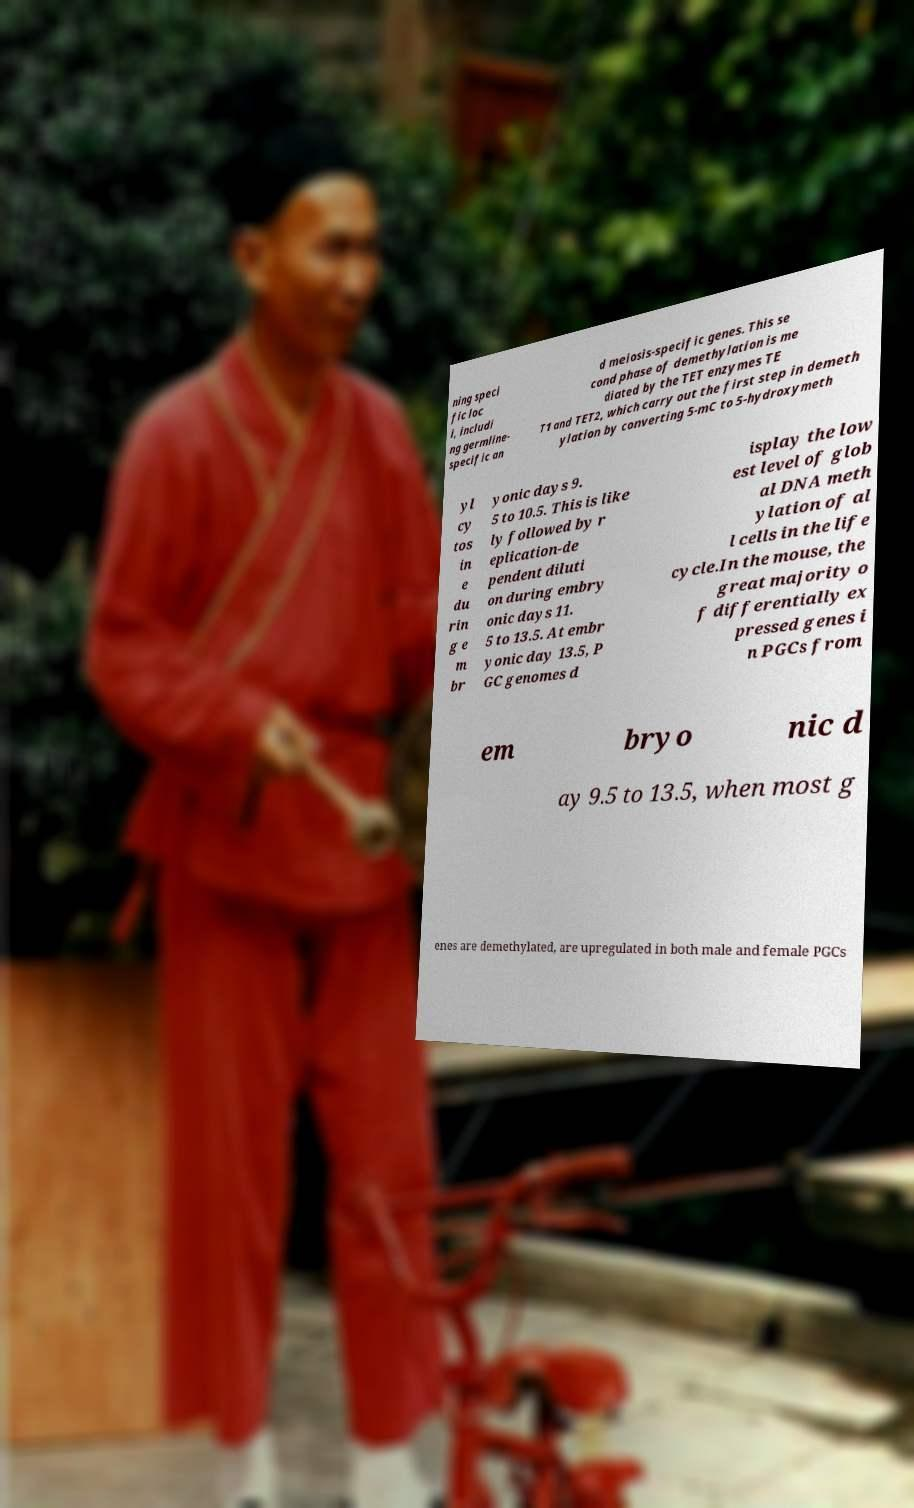Could you extract and type out the text from this image? ning speci fic loc i, includi ng germline- specific an d meiosis-specific genes. This se cond phase of demethylation is me diated by the TET enzymes TE T1 and TET2, which carry out the first step in demeth ylation by converting 5-mC to 5-hydroxymeth yl cy tos in e du rin g e m br yonic days 9. 5 to 10.5. This is like ly followed by r eplication-de pendent diluti on during embry onic days 11. 5 to 13.5. At embr yonic day 13.5, P GC genomes d isplay the low est level of glob al DNA meth ylation of al l cells in the life cycle.In the mouse, the great majority o f differentially ex pressed genes i n PGCs from em bryo nic d ay 9.5 to 13.5, when most g enes are demethylated, are upregulated in both male and female PGCs 